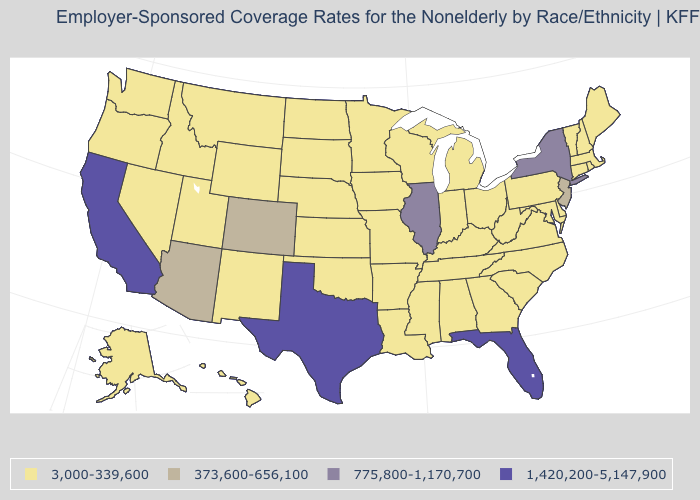What is the value of South Carolina?
Write a very short answer. 3,000-339,600. Which states have the lowest value in the USA?
Answer briefly. Alabama, Alaska, Arkansas, Connecticut, Delaware, Georgia, Hawaii, Idaho, Indiana, Iowa, Kansas, Kentucky, Louisiana, Maine, Maryland, Massachusetts, Michigan, Minnesota, Mississippi, Missouri, Montana, Nebraska, Nevada, New Hampshire, New Mexico, North Carolina, North Dakota, Ohio, Oklahoma, Oregon, Pennsylvania, Rhode Island, South Carolina, South Dakota, Tennessee, Utah, Vermont, Virginia, Washington, West Virginia, Wisconsin, Wyoming. What is the value of Wyoming?
Give a very brief answer. 3,000-339,600. What is the lowest value in the USA?
Answer briefly. 3,000-339,600. What is the value of Louisiana?
Quick response, please. 3,000-339,600. Name the states that have a value in the range 1,420,200-5,147,900?
Quick response, please. California, Florida, Texas. Does Rhode Island have the lowest value in the USA?
Keep it brief. Yes. What is the lowest value in the South?
Write a very short answer. 3,000-339,600. Name the states that have a value in the range 373,600-656,100?
Short answer required. Arizona, Colorado, New Jersey. Name the states that have a value in the range 3,000-339,600?
Keep it brief. Alabama, Alaska, Arkansas, Connecticut, Delaware, Georgia, Hawaii, Idaho, Indiana, Iowa, Kansas, Kentucky, Louisiana, Maine, Maryland, Massachusetts, Michigan, Minnesota, Mississippi, Missouri, Montana, Nebraska, Nevada, New Hampshire, New Mexico, North Carolina, North Dakota, Ohio, Oklahoma, Oregon, Pennsylvania, Rhode Island, South Carolina, South Dakota, Tennessee, Utah, Vermont, Virginia, Washington, West Virginia, Wisconsin, Wyoming. What is the highest value in the USA?
Give a very brief answer. 1,420,200-5,147,900. Does the map have missing data?
Give a very brief answer. No. Is the legend a continuous bar?
Keep it brief. No. Does Texas have the highest value in the USA?
Answer briefly. Yes. What is the lowest value in the USA?
Short answer required. 3,000-339,600. 